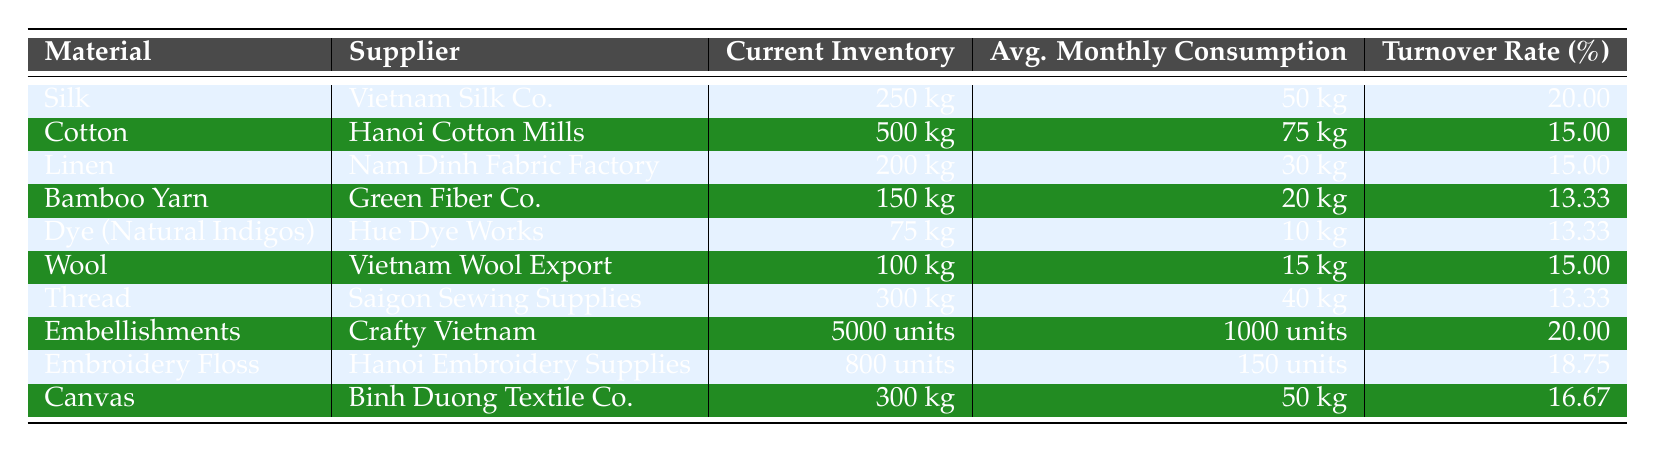What is the current inventory level of Silk? The table lists the current inventory levels for various materials, and for Silk, it specifically states that the inventory is 250 kg.
Answer: 250 kg Which material has the highest average monthly consumption? Comparing the average monthly consumption values across all materials, Cotton has 75 kg, which is higher than the others: 75 (Cotton) > 50 (Silk), 30 (Linen), 20 (Bamboo Yarn), 10 (Dye), 15 (Wool), 40 (Thread), 1000 (Embellishments), 150 (Embroidery Floss), 50 (Canvas).
Answer: Cotton Is the turnover rate for Embellishments higher than that for Thread? The turnover rate for Embellishments is 20.00%, and for Thread, it is 13.33%. Since 20.00% > 13.33%, it is true that the Embellishments turnover rate is higher.
Answer: Yes What is the total current inventory of Cotton and Canvas combined? To find the total current inventory, add the inventory for Cotton (500 kg) and Canvas (300 kg): 500 + 300 = 800 kg.
Answer: 800 kg How much more average monthly consumption does Cotton have compared to Bamboo Yarn? Cotton's average monthly consumption is 75 kg, and Bamboo Yarn's is 20 kg. The difference between them is 75 - 20 = 55 kg.
Answer: 55 kg Is the turnover rate for Wool the same as that for Linen? Wool's turnover rate is 15.00%, and Linen's is also 15.00%. Since both rates are equal, the statement is true.
Answer: Yes What is the average turnover rate of all materials listed in the table? We need to sum the turnover rates of each material (20 + 15 + 15 + 13.33 + 13.33 + 15 + 13.33 + 20 + 18.75 + 16.67 =  1.65), and divide by the number of items (10): 1.65%/10 = 16.50%.
Answer: 16.50% Which supplier provides the material with the least current inventory? The table shows that Dye (Natural Indigos) has the least current inventory at 75 kg, supplied by Hue Dye Works. Hence, it is the supplier with the least current inventory.
Answer: Hue Dye Works If you combine the average monthly consumptions of Silk, Wool, and Linen, what is the total? Sum the average monthly consumptions: 50 (Silk) + 15 (Wool) + 30 (Linen) = 95 kg.
Answer: 95 kg Which material has a turnover rate higher than 18%? From the table, only Embellishments has a turnover rate of 20.00%, which is higher than 18%. Therefore, Embellishments is the material that meets this criterion.
Answer: Embellishments 